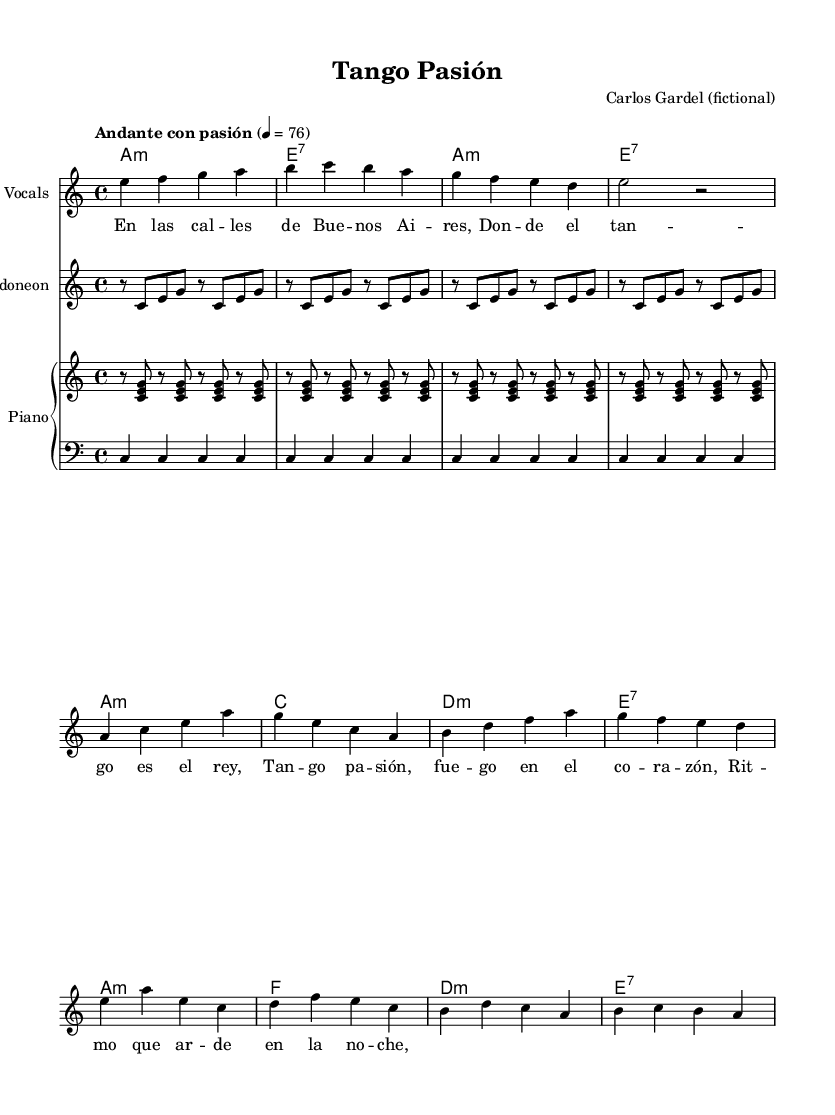What is the key signature of this music? The key signature is indicated at the beginning of the staff. In this case, it is A minor, which is represented by no sharps or flats.
Answer: A minor What is the time signature of the piece? The time signature is located at the beginning of the piece and is shown as 4/4, meaning there are four beats in each measure.
Answer: 4/4 What is the tempo marking for this composition? The tempo marking is found at the beginning of the score, under "Andante con pasión," indicating the piece should be played at a moderate pace with passion.
Answer: Andante con pasión How many measures are in the provided music? The total number of measures can be counted in the melody for the introduction, verse, and chorus sections. Counting yields a total of 12 measures.
Answer: 12 What instruments are included in this arrangement? The instruments can be identified from the score. It includes vocals, bandoneon, and piano (with a separate treble and bass staff).
Answer: Vocals, bandoneon, piano What type of song is represented in this sheet music? The style of the song is indicated in the context—tags like "Tango Pasión" and the presence of bandoneon suggest that it is a tango.
Answer: Tango 